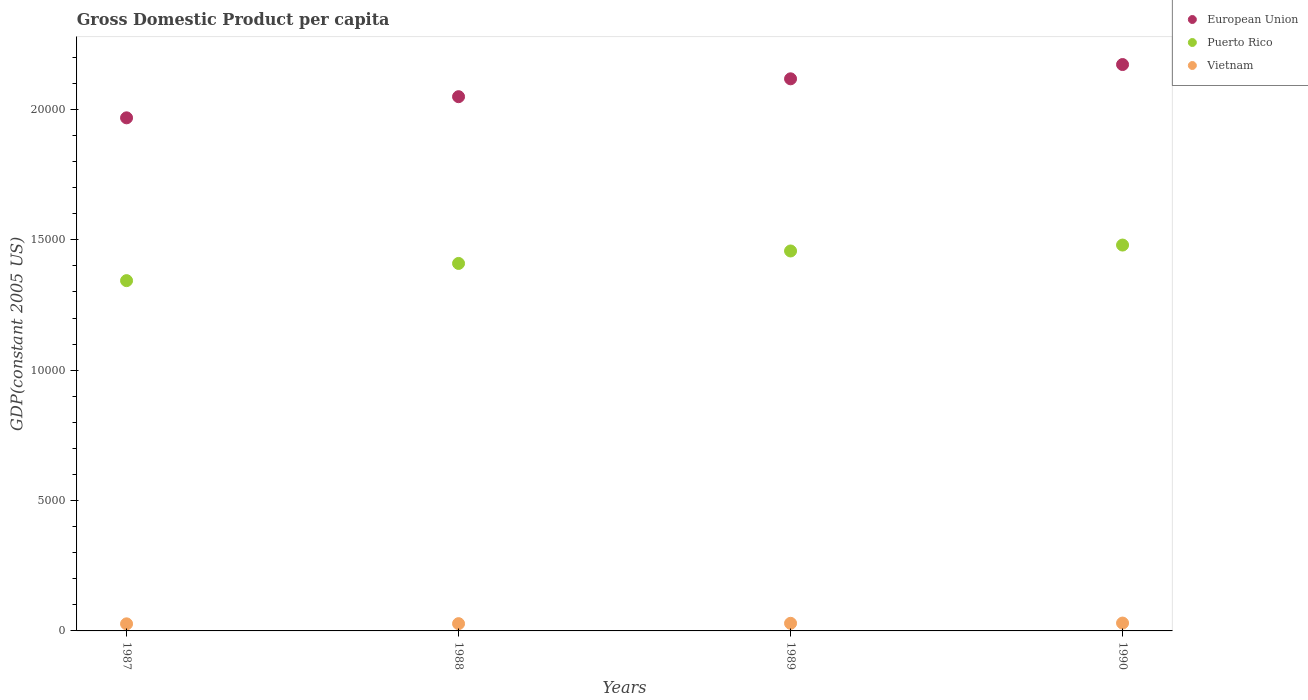Is the number of dotlines equal to the number of legend labels?
Give a very brief answer. Yes. What is the GDP per capita in Puerto Rico in 1990?
Offer a very short reply. 1.48e+04. Across all years, what is the maximum GDP per capita in Vietnam?
Give a very brief answer. 301.31. Across all years, what is the minimum GDP per capita in Puerto Rico?
Provide a short and direct response. 1.34e+04. In which year was the GDP per capita in European Union minimum?
Your answer should be compact. 1987. What is the total GDP per capita in Vietnam in the graph?
Ensure brevity in your answer.  1143.68. What is the difference between the GDP per capita in Vietnam in 1987 and that in 1988?
Keep it short and to the point. -7.12. What is the difference between the GDP per capita in European Union in 1988 and the GDP per capita in Vietnam in 1990?
Provide a succinct answer. 2.02e+04. What is the average GDP per capita in Puerto Rico per year?
Your answer should be very brief. 1.42e+04. In the year 1989, what is the difference between the GDP per capita in Puerto Rico and GDP per capita in European Union?
Keep it short and to the point. -6603.19. What is the ratio of the GDP per capita in Puerto Rico in 1989 to that in 1990?
Make the answer very short. 0.98. What is the difference between the highest and the second highest GDP per capita in Vietnam?
Give a very brief answer. 9.12. What is the difference between the highest and the lowest GDP per capita in Vietnam?
Offer a very short reply. 29.78. Is it the case that in every year, the sum of the GDP per capita in European Union and GDP per capita in Puerto Rico  is greater than the GDP per capita in Vietnam?
Provide a succinct answer. Yes. Does the GDP per capita in European Union monotonically increase over the years?
Make the answer very short. Yes. How many years are there in the graph?
Ensure brevity in your answer.  4. What is the difference between two consecutive major ticks on the Y-axis?
Give a very brief answer. 5000. Are the values on the major ticks of Y-axis written in scientific E-notation?
Offer a very short reply. No. Where does the legend appear in the graph?
Keep it short and to the point. Top right. How many legend labels are there?
Provide a succinct answer. 3. How are the legend labels stacked?
Offer a very short reply. Vertical. What is the title of the graph?
Offer a terse response. Gross Domestic Product per capita. Does "Cote d'Ivoire" appear as one of the legend labels in the graph?
Ensure brevity in your answer.  No. What is the label or title of the Y-axis?
Offer a terse response. GDP(constant 2005 US). What is the GDP(constant 2005 US) in European Union in 1987?
Provide a succinct answer. 1.97e+04. What is the GDP(constant 2005 US) in Puerto Rico in 1987?
Your answer should be compact. 1.34e+04. What is the GDP(constant 2005 US) of Vietnam in 1987?
Your answer should be compact. 271.53. What is the GDP(constant 2005 US) in European Union in 1988?
Give a very brief answer. 2.05e+04. What is the GDP(constant 2005 US) of Puerto Rico in 1988?
Give a very brief answer. 1.41e+04. What is the GDP(constant 2005 US) of Vietnam in 1988?
Provide a short and direct response. 278.65. What is the GDP(constant 2005 US) of European Union in 1989?
Your answer should be compact. 2.12e+04. What is the GDP(constant 2005 US) in Puerto Rico in 1989?
Your answer should be very brief. 1.46e+04. What is the GDP(constant 2005 US) in Vietnam in 1989?
Your response must be concise. 292.19. What is the GDP(constant 2005 US) of European Union in 1990?
Give a very brief answer. 2.17e+04. What is the GDP(constant 2005 US) in Puerto Rico in 1990?
Provide a short and direct response. 1.48e+04. What is the GDP(constant 2005 US) of Vietnam in 1990?
Your answer should be compact. 301.31. Across all years, what is the maximum GDP(constant 2005 US) of European Union?
Offer a very short reply. 2.17e+04. Across all years, what is the maximum GDP(constant 2005 US) of Puerto Rico?
Your response must be concise. 1.48e+04. Across all years, what is the maximum GDP(constant 2005 US) of Vietnam?
Offer a terse response. 301.31. Across all years, what is the minimum GDP(constant 2005 US) in European Union?
Offer a very short reply. 1.97e+04. Across all years, what is the minimum GDP(constant 2005 US) in Puerto Rico?
Provide a succinct answer. 1.34e+04. Across all years, what is the minimum GDP(constant 2005 US) of Vietnam?
Offer a very short reply. 271.53. What is the total GDP(constant 2005 US) of European Union in the graph?
Keep it short and to the point. 8.31e+04. What is the total GDP(constant 2005 US) in Puerto Rico in the graph?
Your response must be concise. 5.69e+04. What is the total GDP(constant 2005 US) in Vietnam in the graph?
Provide a succinct answer. 1143.68. What is the difference between the GDP(constant 2005 US) in European Union in 1987 and that in 1988?
Give a very brief answer. -810.94. What is the difference between the GDP(constant 2005 US) in Puerto Rico in 1987 and that in 1988?
Your response must be concise. -659.86. What is the difference between the GDP(constant 2005 US) of Vietnam in 1987 and that in 1988?
Your answer should be very brief. -7.12. What is the difference between the GDP(constant 2005 US) in European Union in 1987 and that in 1989?
Your answer should be compact. -1496.33. What is the difference between the GDP(constant 2005 US) of Puerto Rico in 1987 and that in 1989?
Offer a terse response. -1137.66. What is the difference between the GDP(constant 2005 US) of Vietnam in 1987 and that in 1989?
Give a very brief answer. -20.66. What is the difference between the GDP(constant 2005 US) in European Union in 1987 and that in 1990?
Your response must be concise. -2043.89. What is the difference between the GDP(constant 2005 US) in Puerto Rico in 1987 and that in 1990?
Give a very brief answer. -1364.64. What is the difference between the GDP(constant 2005 US) in Vietnam in 1987 and that in 1990?
Your answer should be compact. -29.78. What is the difference between the GDP(constant 2005 US) of European Union in 1988 and that in 1989?
Provide a succinct answer. -685.39. What is the difference between the GDP(constant 2005 US) in Puerto Rico in 1988 and that in 1989?
Ensure brevity in your answer.  -477.8. What is the difference between the GDP(constant 2005 US) of Vietnam in 1988 and that in 1989?
Provide a short and direct response. -13.54. What is the difference between the GDP(constant 2005 US) in European Union in 1988 and that in 1990?
Provide a short and direct response. -1232.96. What is the difference between the GDP(constant 2005 US) of Puerto Rico in 1988 and that in 1990?
Your answer should be compact. -704.78. What is the difference between the GDP(constant 2005 US) of Vietnam in 1988 and that in 1990?
Provide a succinct answer. -22.67. What is the difference between the GDP(constant 2005 US) in European Union in 1989 and that in 1990?
Give a very brief answer. -547.57. What is the difference between the GDP(constant 2005 US) in Puerto Rico in 1989 and that in 1990?
Provide a succinct answer. -226.98. What is the difference between the GDP(constant 2005 US) in Vietnam in 1989 and that in 1990?
Give a very brief answer. -9.12. What is the difference between the GDP(constant 2005 US) of European Union in 1987 and the GDP(constant 2005 US) of Puerto Rico in 1988?
Offer a very short reply. 5584.66. What is the difference between the GDP(constant 2005 US) in European Union in 1987 and the GDP(constant 2005 US) in Vietnam in 1988?
Your response must be concise. 1.94e+04. What is the difference between the GDP(constant 2005 US) of Puerto Rico in 1987 and the GDP(constant 2005 US) of Vietnam in 1988?
Your answer should be very brief. 1.32e+04. What is the difference between the GDP(constant 2005 US) of European Union in 1987 and the GDP(constant 2005 US) of Puerto Rico in 1989?
Keep it short and to the point. 5106.86. What is the difference between the GDP(constant 2005 US) of European Union in 1987 and the GDP(constant 2005 US) of Vietnam in 1989?
Offer a terse response. 1.94e+04. What is the difference between the GDP(constant 2005 US) in Puerto Rico in 1987 and the GDP(constant 2005 US) in Vietnam in 1989?
Your response must be concise. 1.31e+04. What is the difference between the GDP(constant 2005 US) in European Union in 1987 and the GDP(constant 2005 US) in Puerto Rico in 1990?
Make the answer very short. 4879.88. What is the difference between the GDP(constant 2005 US) of European Union in 1987 and the GDP(constant 2005 US) of Vietnam in 1990?
Offer a terse response. 1.94e+04. What is the difference between the GDP(constant 2005 US) in Puerto Rico in 1987 and the GDP(constant 2005 US) in Vietnam in 1990?
Your answer should be very brief. 1.31e+04. What is the difference between the GDP(constant 2005 US) in European Union in 1988 and the GDP(constant 2005 US) in Puerto Rico in 1989?
Offer a terse response. 5917.8. What is the difference between the GDP(constant 2005 US) of European Union in 1988 and the GDP(constant 2005 US) of Vietnam in 1989?
Give a very brief answer. 2.02e+04. What is the difference between the GDP(constant 2005 US) of Puerto Rico in 1988 and the GDP(constant 2005 US) of Vietnam in 1989?
Offer a very short reply. 1.38e+04. What is the difference between the GDP(constant 2005 US) of European Union in 1988 and the GDP(constant 2005 US) of Puerto Rico in 1990?
Give a very brief answer. 5690.82. What is the difference between the GDP(constant 2005 US) in European Union in 1988 and the GDP(constant 2005 US) in Vietnam in 1990?
Your answer should be compact. 2.02e+04. What is the difference between the GDP(constant 2005 US) of Puerto Rico in 1988 and the GDP(constant 2005 US) of Vietnam in 1990?
Offer a very short reply. 1.38e+04. What is the difference between the GDP(constant 2005 US) of European Union in 1989 and the GDP(constant 2005 US) of Puerto Rico in 1990?
Offer a terse response. 6376.21. What is the difference between the GDP(constant 2005 US) in European Union in 1989 and the GDP(constant 2005 US) in Vietnam in 1990?
Offer a very short reply. 2.09e+04. What is the difference between the GDP(constant 2005 US) in Puerto Rico in 1989 and the GDP(constant 2005 US) in Vietnam in 1990?
Offer a very short reply. 1.43e+04. What is the average GDP(constant 2005 US) in European Union per year?
Your answer should be very brief. 2.08e+04. What is the average GDP(constant 2005 US) of Puerto Rico per year?
Keep it short and to the point. 1.42e+04. What is the average GDP(constant 2005 US) of Vietnam per year?
Your answer should be very brief. 285.92. In the year 1987, what is the difference between the GDP(constant 2005 US) in European Union and GDP(constant 2005 US) in Puerto Rico?
Ensure brevity in your answer.  6244.52. In the year 1987, what is the difference between the GDP(constant 2005 US) of European Union and GDP(constant 2005 US) of Vietnam?
Provide a succinct answer. 1.94e+04. In the year 1987, what is the difference between the GDP(constant 2005 US) of Puerto Rico and GDP(constant 2005 US) of Vietnam?
Your response must be concise. 1.32e+04. In the year 1988, what is the difference between the GDP(constant 2005 US) of European Union and GDP(constant 2005 US) of Puerto Rico?
Ensure brevity in your answer.  6395.6. In the year 1988, what is the difference between the GDP(constant 2005 US) in European Union and GDP(constant 2005 US) in Vietnam?
Provide a succinct answer. 2.02e+04. In the year 1988, what is the difference between the GDP(constant 2005 US) in Puerto Rico and GDP(constant 2005 US) in Vietnam?
Keep it short and to the point. 1.38e+04. In the year 1989, what is the difference between the GDP(constant 2005 US) of European Union and GDP(constant 2005 US) of Puerto Rico?
Provide a succinct answer. 6603.19. In the year 1989, what is the difference between the GDP(constant 2005 US) of European Union and GDP(constant 2005 US) of Vietnam?
Give a very brief answer. 2.09e+04. In the year 1989, what is the difference between the GDP(constant 2005 US) in Puerto Rico and GDP(constant 2005 US) in Vietnam?
Ensure brevity in your answer.  1.43e+04. In the year 1990, what is the difference between the GDP(constant 2005 US) of European Union and GDP(constant 2005 US) of Puerto Rico?
Your answer should be very brief. 6923.77. In the year 1990, what is the difference between the GDP(constant 2005 US) in European Union and GDP(constant 2005 US) in Vietnam?
Your response must be concise. 2.14e+04. In the year 1990, what is the difference between the GDP(constant 2005 US) in Puerto Rico and GDP(constant 2005 US) in Vietnam?
Offer a very short reply. 1.45e+04. What is the ratio of the GDP(constant 2005 US) in European Union in 1987 to that in 1988?
Your answer should be compact. 0.96. What is the ratio of the GDP(constant 2005 US) of Puerto Rico in 1987 to that in 1988?
Offer a very short reply. 0.95. What is the ratio of the GDP(constant 2005 US) of Vietnam in 1987 to that in 1988?
Keep it short and to the point. 0.97. What is the ratio of the GDP(constant 2005 US) in European Union in 1987 to that in 1989?
Make the answer very short. 0.93. What is the ratio of the GDP(constant 2005 US) in Puerto Rico in 1987 to that in 1989?
Make the answer very short. 0.92. What is the ratio of the GDP(constant 2005 US) in Vietnam in 1987 to that in 1989?
Provide a short and direct response. 0.93. What is the ratio of the GDP(constant 2005 US) in European Union in 1987 to that in 1990?
Give a very brief answer. 0.91. What is the ratio of the GDP(constant 2005 US) in Puerto Rico in 1987 to that in 1990?
Give a very brief answer. 0.91. What is the ratio of the GDP(constant 2005 US) of Vietnam in 1987 to that in 1990?
Provide a succinct answer. 0.9. What is the ratio of the GDP(constant 2005 US) in European Union in 1988 to that in 1989?
Offer a terse response. 0.97. What is the ratio of the GDP(constant 2005 US) in Puerto Rico in 1988 to that in 1989?
Your response must be concise. 0.97. What is the ratio of the GDP(constant 2005 US) of Vietnam in 1988 to that in 1989?
Provide a succinct answer. 0.95. What is the ratio of the GDP(constant 2005 US) in European Union in 1988 to that in 1990?
Offer a terse response. 0.94. What is the ratio of the GDP(constant 2005 US) in Puerto Rico in 1988 to that in 1990?
Give a very brief answer. 0.95. What is the ratio of the GDP(constant 2005 US) in Vietnam in 1988 to that in 1990?
Your answer should be very brief. 0.92. What is the ratio of the GDP(constant 2005 US) of European Union in 1989 to that in 1990?
Your answer should be very brief. 0.97. What is the ratio of the GDP(constant 2005 US) of Puerto Rico in 1989 to that in 1990?
Offer a very short reply. 0.98. What is the ratio of the GDP(constant 2005 US) in Vietnam in 1989 to that in 1990?
Offer a very short reply. 0.97. What is the difference between the highest and the second highest GDP(constant 2005 US) of European Union?
Your response must be concise. 547.57. What is the difference between the highest and the second highest GDP(constant 2005 US) of Puerto Rico?
Provide a short and direct response. 226.98. What is the difference between the highest and the second highest GDP(constant 2005 US) of Vietnam?
Give a very brief answer. 9.12. What is the difference between the highest and the lowest GDP(constant 2005 US) in European Union?
Offer a terse response. 2043.89. What is the difference between the highest and the lowest GDP(constant 2005 US) in Puerto Rico?
Offer a very short reply. 1364.64. What is the difference between the highest and the lowest GDP(constant 2005 US) of Vietnam?
Provide a short and direct response. 29.78. 